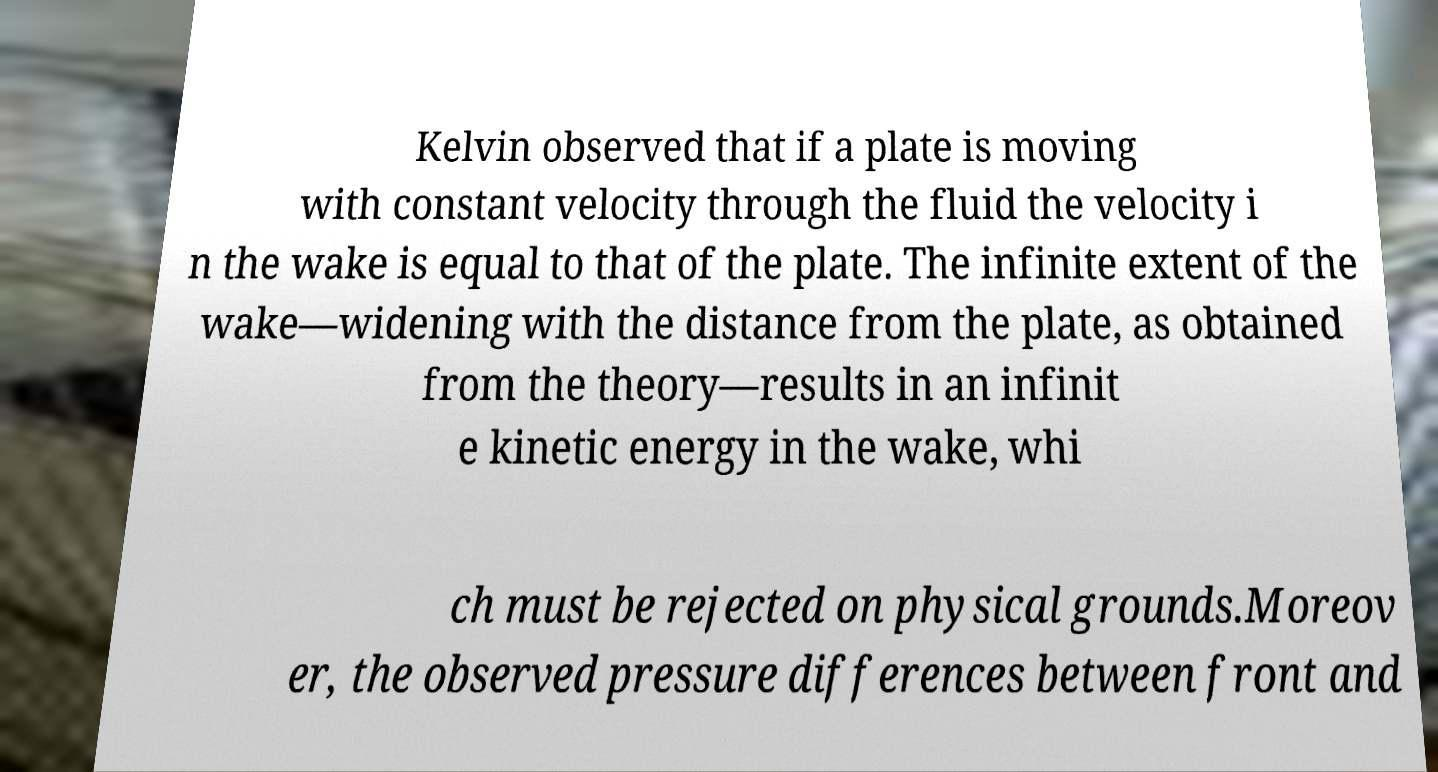For documentation purposes, I need the text within this image transcribed. Could you provide that? Kelvin observed that if a plate is moving with constant velocity through the fluid the velocity i n the wake is equal to that of the plate. The infinite extent of the wake—widening with the distance from the plate, as obtained from the theory—results in an infinit e kinetic energy in the wake, whi ch must be rejected on physical grounds.Moreov er, the observed pressure differences between front and 